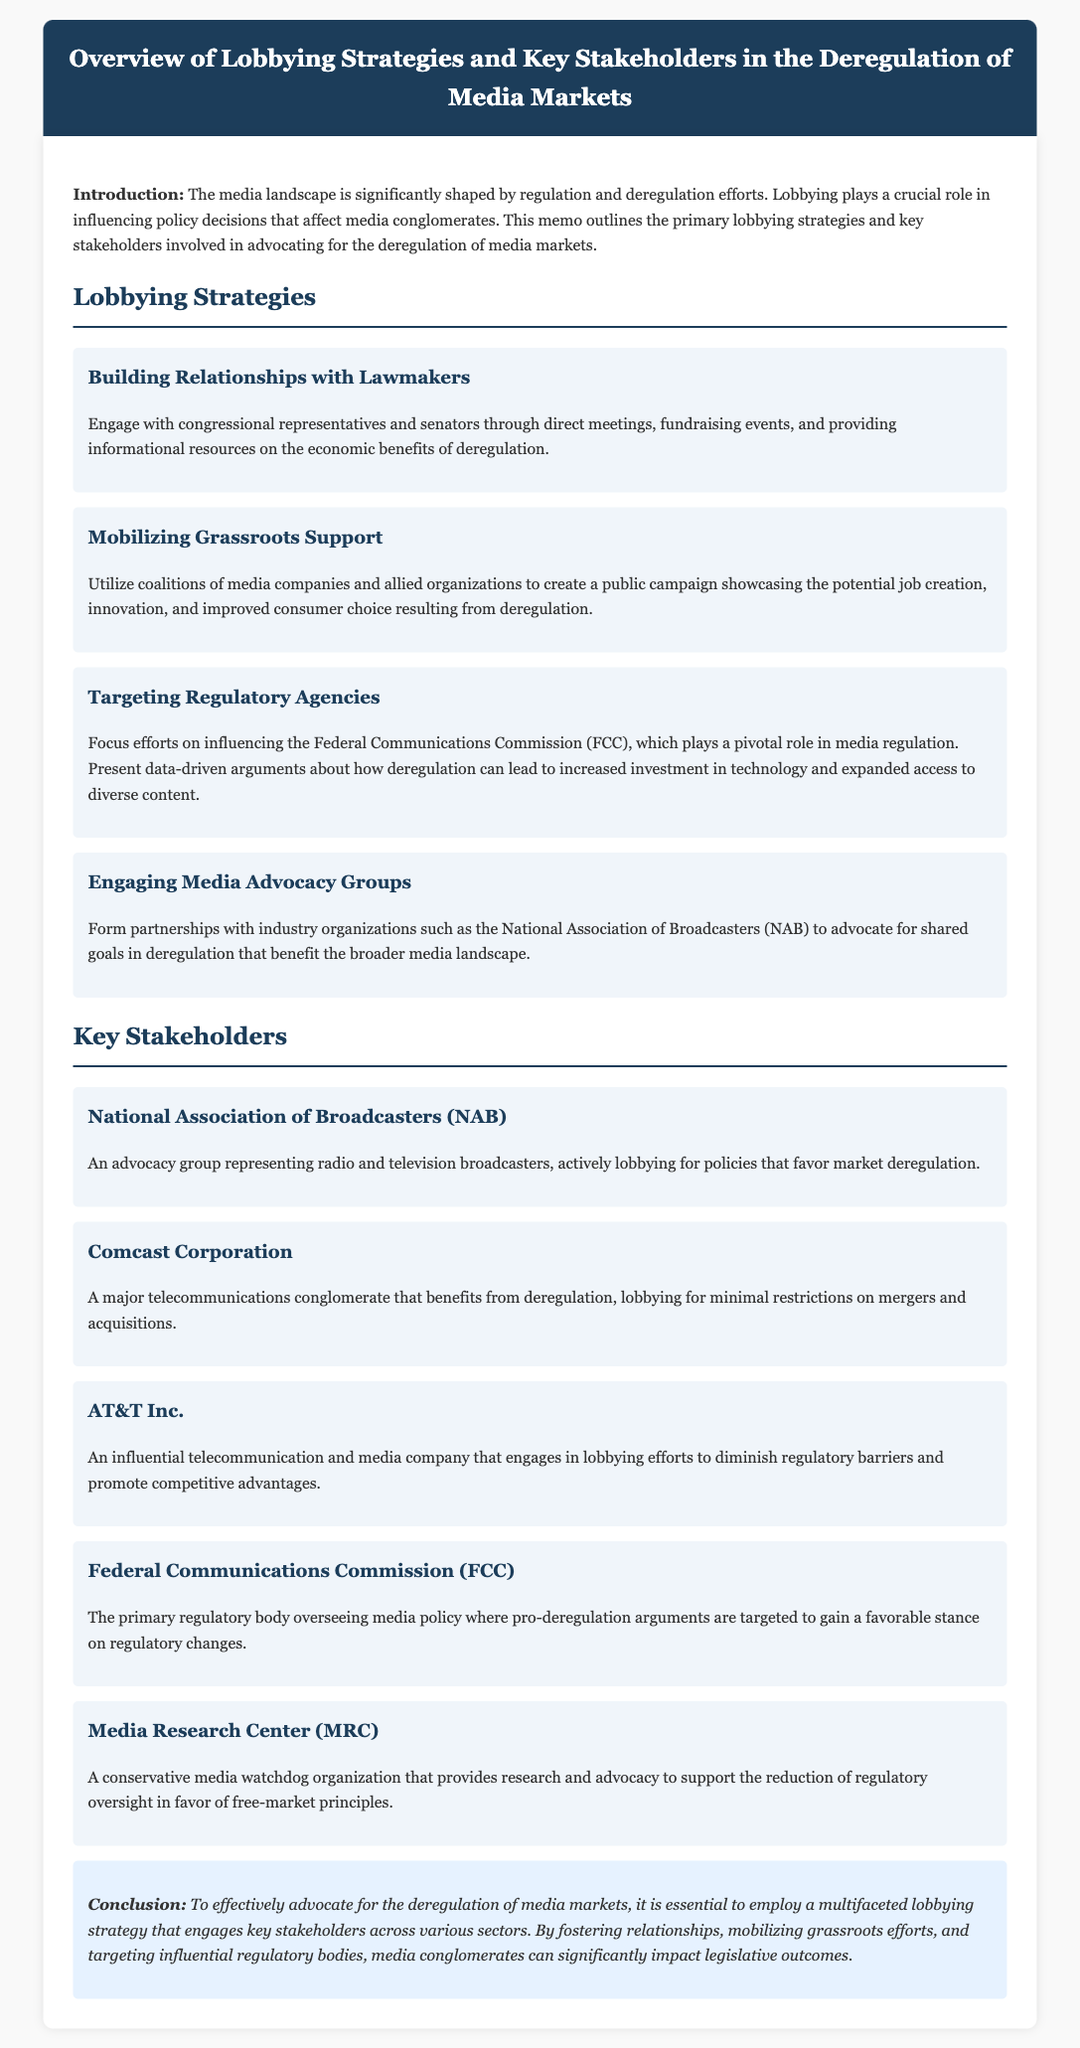what is the title of the memo? The title is explicitly stated in the header of the memo.
Answer: Overview of Lobbying Strategies and Key Stakeholders in the Deregulation of Media Markets who does the National Association of Broadcasters represent? The document specifies who the NAB advocates for.
Answer: radio and television broadcasters which federal agency is primarily targeted for lobbying efforts? The document mentions the agency that plays a pivotal role in media regulation.
Answer: Federal Communications Commission (FCC) what is one strategy for engaging lawmakers? The memo outlines various lobbying strategies, including how to interact with lawmakers.
Answer: Building Relationships with Lawmakers which company lobbies for minimal restrictions on mergers? The stakeholders section identifies companies and their lobbying focuses.
Answer: Comcast Corporation which organization provides research to support free-market principles? The document includes information about stakeholders and their advocacy roles.
Answer: Media Research Center (MRC) what type of campaign is used to mobilize grassroots support? The memo describes campaigns utilized to influence public perception on deregulation.
Answer: public campaign how many key stakeholders are mentioned in the document? A counting of distinct stakeholders listed in the memo provides the answer.
Answer: five 